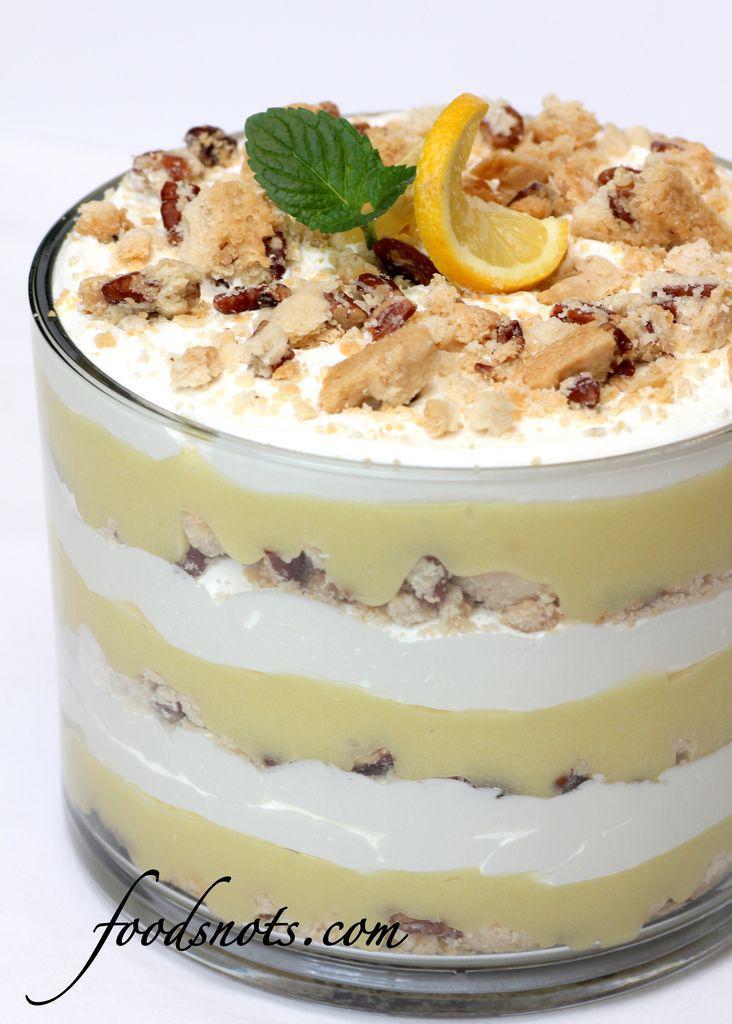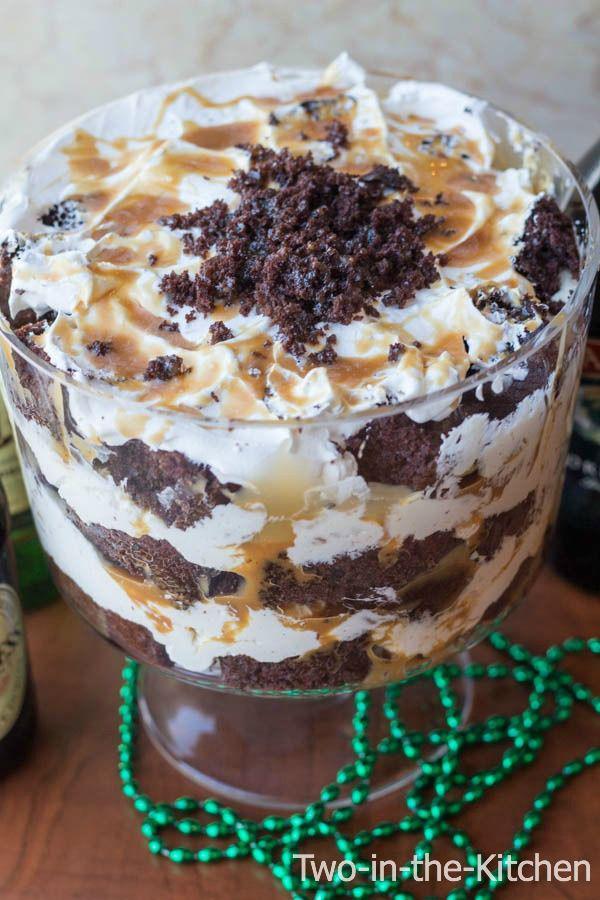The first image is the image on the left, the second image is the image on the right. For the images shown, is this caption "One image shows at least one fancy individual serving dessert." true? Answer yes or no. No. 